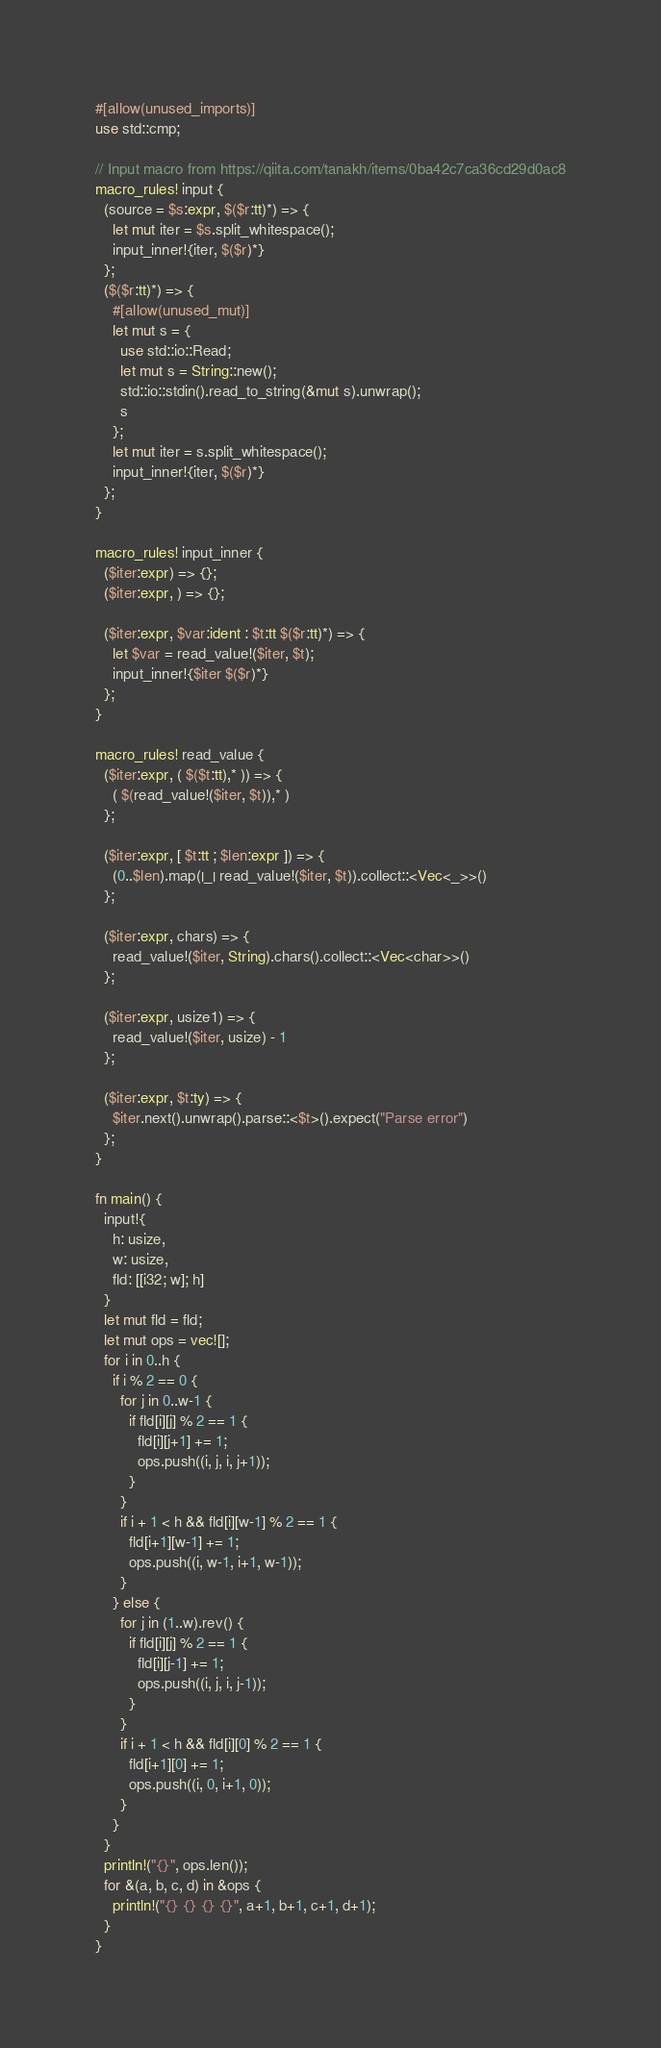<code> <loc_0><loc_0><loc_500><loc_500><_Rust_>#[allow(unused_imports)]
use std::cmp;

// Input macro from https://qiita.com/tanakh/items/0ba42c7ca36cd29d0ac8
macro_rules! input {
  (source = $s:expr, $($r:tt)*) => {
    let mut iter = $s.split_whitespace();
    input_inner!{iter, $($r)*}
  };
  ($($r:tt)*) => {
    #[allow(unused_mut)]
    let mut s = {
      use std::io::Read;
      let mut s = String::new();
      std::io::stdin().read_to_string(&mut s).unwrap();
      s
    };
    let mut iter = s.split_whitespace();
    input_inner!{iter, $($r)*}
  };
}

macro_rules! input_inner {
  ($iter:expr) => {};
  ($iter:expr, ) => {};

  ($iter:expr, $var:ident : $t:tt $($r:tt)*) => {
    let $var = read_value!($iter, $t);
    input_inner!{$iter $($r)*}
  };
}

macro_rules! read_value {
  ($iter:expr, ( $($t:tt),* )) => {
    ( $(read_value!($iter, $t)),* )
  };

  ($iter:expr, [ $t:tt ; $len:expr ]) => {
    (0..$len).map(|_| read_value!($iter, $t)).collect::<Vec<_>>()
  };

  ($iter:expr, chars) => {
    read_value!($iter, String).chars().collect::<Vec<char>>()
  };

  ($iter:expr, usize1) => {
    read_value!($iter, usize) - 1
  };

  ($iter:expr, $t:ty) => {
    $iter.next().unwrap().parse::<$t>().expect("Parse error")
  };
}

fn main() {
  input!{
    h: usize,
    w: usize,
    fld: [[i32; w]; h]
  }
  let mut fld = fld;
  let mut ops = vec![];
  for i in 0..h {
    if i % 2 == 0 {
      for j in 0..w-1 {
        if fld[i][j] % 2 == 1 {
          fld[i][j+1] += 1;
          ops.push((i, j, i, j+1));
        }
      }
      if i + 1 < h && fld[i][w-1] % 2 == 1 {
        fld[i+1][w-1] += 1;
        ops.push((i, w-1, i+1, w-1));
      }
    } else {
      for j in (1..w).rev() {
        if fld[i][j] % 2 == 1 {
          fld[i][j-1] += 1;
          ops.push((i, j, i, j-1));
        }
      }
      if i + 1 < h && fld[i][0] % 2 == 1 {
        fld[i+1][0] += 1;
        ops.push((i, 0, i+1, 0));
      }
    }
  }
  println!("{}", ops.len());
  for &(a, b, c, d) in &ops {
    println!("{} {} {} {}", a+1, b+1, c+1, d+1);
  }
}
</code> 